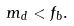Convert formula to latex. <formula><loc_0><loc_0><loc_500><loc_500>m _ { d } < f _ { b } .</formula> 